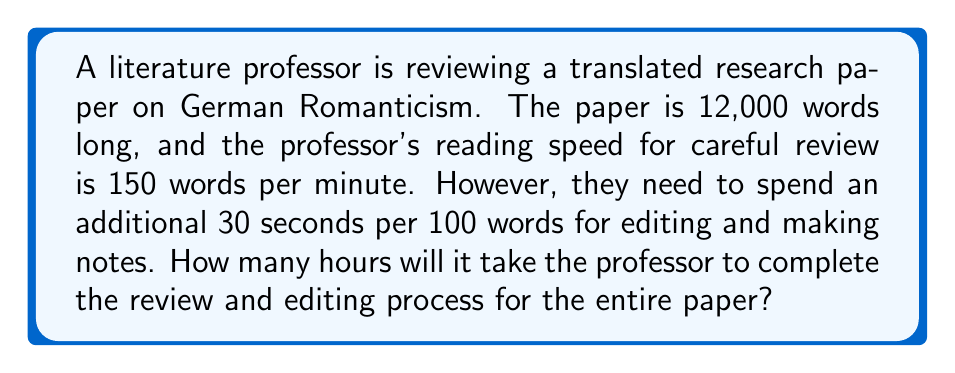Give your solution to this math problem. Let's break this problem down into steps:

1. Calculate the time needed for reading:
   * Words in the paper: 12,000
   * Reading speed: 150 words/minute
   * Reading time = $\frac{12,000 \text{ words}}{150 \text{ words/minute}} = 80 \text{ minutes}$

2. Calculate the time needed for editing:
   * Editing time per 100 words: 30 seconds
   * Editing time for 12,000 words = $\frac{12,000}{100} \times 30 \text{ seconds} = 3,600 \text{ seconds} = 60 \text{ minutes}$

3. Calculate the total time:
   * Total time = Reading time + Editing time
   * Total time = $80 \text{ minutes} + 60 \text{ minutes} = 140 \text{ minutes}$

4. Convert minutes to hours:
   * Hours = $\frac{140 \text{ minutes}}{60 \text{ minutes/hour}} = \frac{7}{3} \text{ hours}$

Therefore, it will take the professor $\frac{7}{3}$ hours or 2 hours and 20 minutes to complete the review and editing process.
Answer: $\frac{7}{3}$ hours or 2 hours and 20 minutes 